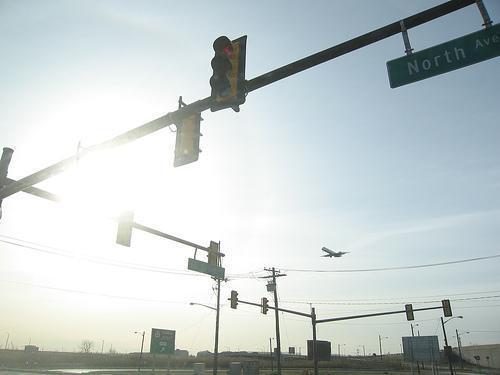How many planes are in this picture?
Give a very brief answer. 1. 